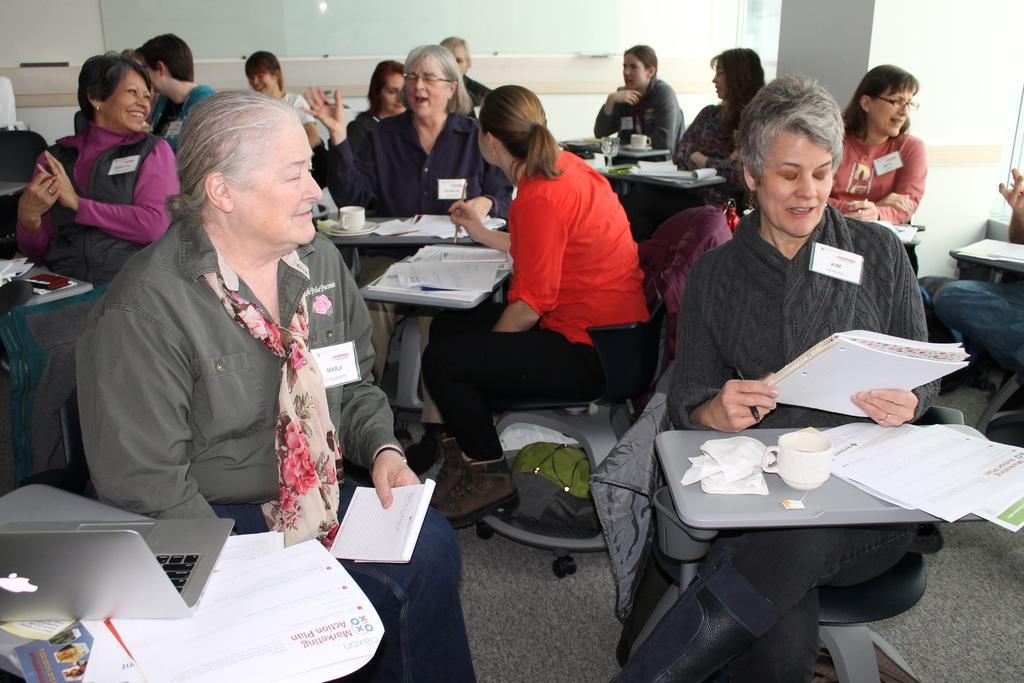Describe this image in one or two sentences. This image is taken inside a room. In this image there are many people sitting on the chairs. In the left side of the image a woman is sitting on the chair holding a paper in her hand, she is wearing a scarf and there is a table and on top of that there are few papers and laptop. In the right side of the image a woman is sitting on a chair holding a book in her hand. In the middle of the image there is a table and top of it there is a cup and saucer. In the background there is a wall and a pillar. In the bottom of the image there is a floor with mat. 